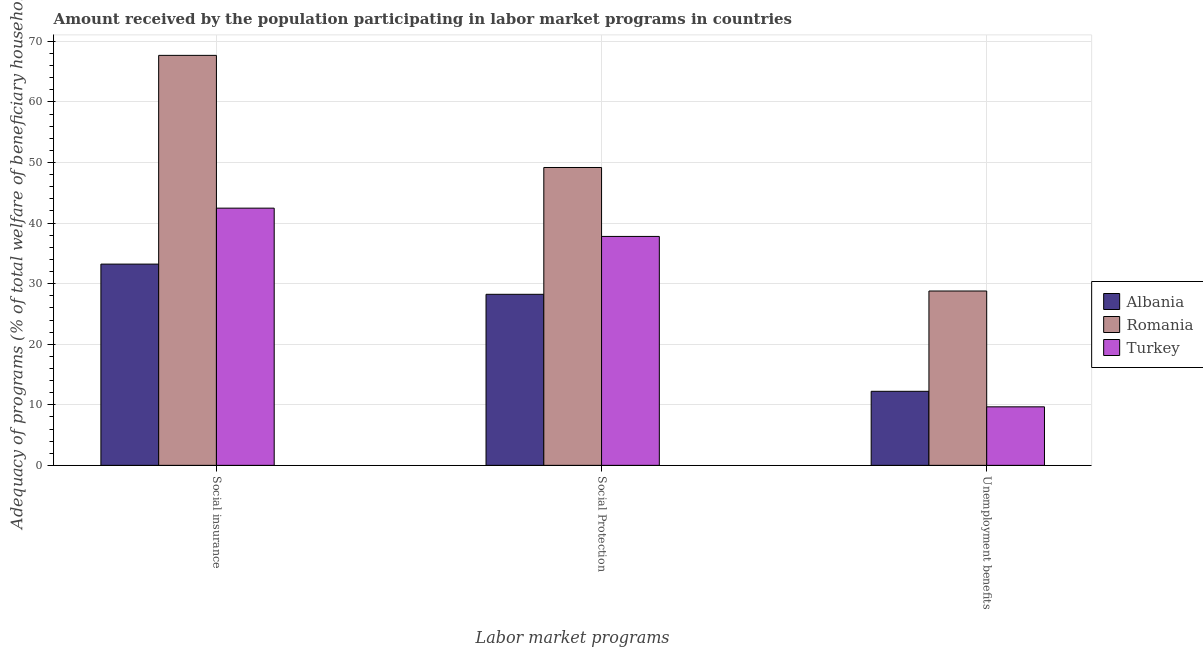How many groups of bars are there?
Offer a very short reply. 3. Are the number of bars on each tick of the X-axis equal?
Keep it short and to the point. Yes. How many bars are there on the 3rd tick from the right?
Ensure brevity in your answer.  3. What is the label of the 1st group of bars from the left?
Keep it short and to the point. Social insurance. What is the amount received by the population participating in social protection programs in Albania?
Provide a short and direct response. 28.24. Across all countries, what is the maximum amount received by the population participating in social protection programs?
Offer a very short reply. 49.18. Across all countries, what is the minimum amount received by the population participating in unemployment benefits programs?
Make the answer very short. 9.66. In which country was the amount received by the population participating in unemployment benefits programs maximum?
Ensure brevity in your answer.  Romania. In which country was the amount received by the population participating in unemployment benefits programs minimum?
Give a very brief answer. Turkey. What is the total amount received by the population participating in social insurance programs in the graph?
Keep it short and to the point. 143.4. What is the difference between the amount received by the population participating in unemployment benefits programs in Turkey and that in Romania?
Your response must be concise. -19.12. What is the difference between the amount received by the population participating in social protection programs in Turkey and the amount received by the population participating in unemployment benefits programs in Romania?
Offer a very short reply. 9.01. What is the average amount received by the population participating in unemployment benefits programs per country?
Keep it short and to the point. 16.89. What is the difference between the amount received by the population participating in unemployment benefits programs and amount received by the population participating in social protection programs in Romania?
Offer a very short reply. -20.4. In how many countries, is the amount received by the population participating in social insurance programs greater than 30 %?
Offer a very short reply. 3. What is the ratio of the amount received by the population participating in social protection programs in Romania to that in Turkey?
Provide a succinct answer. 1.3. Is the amount received by the population participating in social insurance programs in Romania less than that in Turkey?
Your answer should be compact. No. Is the difference between the amount received by the population participating in social protection programs in Romania and Turkey greater than the difference between the amount received by the population participating in unemployment benefits programs in Romania and Turkey?
Your response must be concise. No. What is the difference between the highest and the second highest amount received by the population participating in unemployment benefits programs?
Your answer should be very brief. 16.56. What is the difference between the highest and the lowest amount received by the population participating in unemployment benefits programs?
Your answer should be compact. 19.12. In how many countries, is the amount received by the population participating in unemployment benefits programs greater than the average amount received by the population participating in unemployment benefits programs taken over all countries?
Provide a short and direct response. 1. Is the sum of the amount received by the population participating in unemployment benefits programs in Turkey and Albania greater than the maximum amount received by the population participating in social insurance programs across all countries?
Ensure brevity in your answer.  No. What does the 2nd bar from the left in Social Protection represents?
Provide a short and direct response. Romania. What does the 3rd bar from the right in Social insurance represents?
Offer a very short reply. Albania. Are all the bars in the graph horizontal?
Provide a short and direct response. No. How many countries are there in the graph?
Your answer should be very brief. 3. What is the difference between two consecutive major ticks on the Y-axis?
Offer a terse response. 10. Does the graph contain any zero values?
Provide a short and direct response. No. What is the title of the graph?
Your response must be concise. Amount received by the population participating in labor market programs in countries. Does "Andorra" appear as one of the legend labels in the graph?
Make the answer very short. No. What is the label or title of the X-axis?
Ensure brevity in your answer.  Labor market programs. What is the label or title of the Y-axis?
Provide a succinct answer. Adequacy of programs (% of total welfare of beneficiary households). What is the Adequacy of programs (% of total welfare of beneficiary households) in Albania in Social insurance?
Provide a succinct answer. 33.23. What is the Adequacy of programs (% of total welfare of beneficiary households) in Romania in Social insurance?
Provide a short and direct response. 67.7. What is the Adequacy of programs (% of total welfare of beneficiary households) in Turkey in Social insurance?
Give a very brief answer. 42.47. What is the Adequacy of programs (% of total welfare of beneficiary households) in Albania in Social Protection?
Your answer should be very brief. 28.24. What is the Adequacy of programs (% of total welfare of beneficiary households) of Romania in Social Protection?
Your answer should be very brief. 49.18. What is the Adequacy of programs (% of total welfare of beneficiary households) in Turkey in Social Protection?
Keep it short and to the point. 37.8. What is the Adequacy of programs (% of total welfare of beneficiary households) in Albania in Unemployment benefits?
Offer a terse response. 12.23. What is the Adequacy of programs (% of total welfare of beneficiary households) in Romania in Unemployment benefits?
Your answer should be compact. 28.79. What is the Adequacy of programs (% of total welfare of beneficiary households) in Turkey in Unemployment benefits?
Provide a succinct answer. 9.66. Across all Labor market programs, what is the maximum Adequacy of programs (% of total welfare of beneficiary households) of Albania?
Provide a short and direct response. 33.23. Across all Labor market programs, what is the maximum Adequacy of programs (% of total welfare of beneficiary households) in Romania?
Your answer should be compact. 67.7. Across all Labor market programs, what is the maximum Adequacy of programs (% of total welfare of beneficiary households) of Turkey?
Provide a succinct answer. 42.47. Across all Labor market programs, what is the minimum Adequacy of programs (% of total welfare of beneficiary households) in Albania?
Your answer should be very brief. 12.23. Across all Labor market programs, what is the minimum Adequacy of programs (% of total welfare of beneficiary households) in Romania?
Provide a succinct answer. 28.79. Across all Labor market programs, what is the minimum Adequacy of programs (% of total welfare of beneficiary households) in Turkey?
Ensure brevity in your answer.  9.66. What is the total Adequacy of programs (% of total welfare of beneficiary households) of Albania in the graph?
Offer a very short reply. 73.7. What is the total Adequacy of programs (% of total welfare of beneficiary households) in Romania in the graph?
Give a very brief answer. 145.67. What is the total Adequacy of programs (% of total welfare of beneficiary households) of Turkey in the graph?
Provide a short and direct response. 89.93. What is the difference between the Adequacy of programs (% of total welfare of beneficiary households) in Albania in Social insurance and that in Social Protection?
Make the answer very short. 4.99. What is the difference between the Adequacy of programs (% of total welfare of beneficiary households) in Romania in Social insurance and that in Social Protection?
Provide a short and direct response. 18.51. What is the difference between the Adequacy of programs (% of total welfare of beneficiary households) of Turkey in Social insurance and that in Social Protection?
Provide a succinct answer. 4.67. What is the difference between the Adequacy of programs (% of total welfare of beneficiary households) of Albania in Social insurance and that in Unemployment benefits?
Your answer should be compact. 21.01. What is the difference between the Adequacy of programs (% of total welfare of beneficiary households) in Romania in Social insurance and that in Unemployment benefits?
Ensure brevity in your answer.  38.91. What is the difference between the Adequacy of programs (% of total welfare of beneficiary households) in Turkey in Social insurance and that in Unemployment benefits?
Give a very brief answer. 32.81. What is the difference between the Adequacy of programs (% of total welfare of beneficiary households) in Albania in Social Protection and that in Unemployment benefits?
Ensure brevity in your answer.  16.02. What is the difference between the Adequacy of programs (% of total welfare of beneficiary households) in Romania in Social Protection and that in Unemployment benefits?
Give a very brief answer. 20.4. What is the difference between the Adequacy of programs (% of total welfare of beneficiary households) of Turkey in Social Protection and that in Unemployment benefits?
Your answer should be very brief. 28.14. What is the difference between the Adequacy of programs (% of total welfare of beneficiary households) of Albania in Social insurance and the Adequacy of programs (% of total welfare of beneficiary households) of Romania in Social Protection?
Provide a succinct answer. -15.95. What is the difference between the Adequacy of programs (% of total welfare of beneficiary households) in Albania in Social insurance and the Adequacy of programs (% of total welfare of beneficiary households) in Turkey in Social Protection?
Offer a terse response. -4.57. What is the difference between the Adequacy of programs (% of total welfare of beneficiary households) in Romania in Social insurance and the Adequacy of programs (% of total welfare of beneficiary households) in Turkey in Social Protection?
Offer a terse response. 29.9. What is the difference between the Adequacy of programs (% of total welfare of beneficiary households) in Albania in Social insurance and the Adequacy of programs (% of total welfare of beneficiary households) in Romania in Unemployment benefits?
Give a very brief answer. 4.44. What is the difference between the Adequacy of programs (% of total welfare of beneficiary households) of Albania in Social insurance and the Adequacy of programs (% of total welfare of beneficiary households) of Turkey in Unemployment benefits?
Offer a very short reply. 23.57. What is the difference between the Adequacy of programs (% of total welfare of beneficiary households) in Romania in Social insurance and the Adequacy of programs (% of total welfare of beneficiary households) in Turkey in Unemployment benefits?
Keep it short and to the point. 58.03. What is the difference between the Adequacy of programs (% of total welfare of beneficiary households) of Albania in Social Protection and the Adequacy of programs (% of total welfare of beneficiary households) of Romania in Unemployment benefits?
Keep it short and to the point. -0.54. What is the difference between the Adequacy of programs (% of total welfare of beneficiary households) of Albania in Social Protection and the Adequacy of programs (% of total welfare of beneficiary households) of Turkey in Unemployment benefits?
Make the answer very short. 18.58. What is the difference between the Adequacy of programs (% of total welfare of beneficiary households) in Romania in Social Protection and the Adequacy of programs (% of total welfare of beneficiary households) in Turkey in Unemployment benefits?
Provide a succinct answer. 39.52. What is the average Adequacy of programs (% of total welfare of beneficiary households) of Albania per Labor market programs?
Provide a short and direct response. 24.57. What is the average Adequacy of programs (% of total welfare of beneficiary households) of Romania per Labor market programs?
Provide a succinct answer. 48.56. What is the average Adequacy of programs (% of total welfare of beneficiary households) in Turkey per Labor market programs?
Make the answer very short. 29.98. What is the difference between the Adequacy of programs (% of total welfare of beneficiary households) of Albania and Adequacy of programs (% of total welfare of beneficiary households) of Romania in Social insurance?
Your response must be concise. -34.47. What is the difference between the Adequacy of programs (% of total welfare of beneficiary households) in Albania and Adequacy of programs (% of total welfare of beneficiary households) in Turkey in Social insurance?
Give a very brief answer. -9.24. What is the difference between the Adequacy of programs (% of total welfare of beneficiary households) of Romania and Adequacy of programs (% of total welfare of beneficiary households) of Turkey in Social insurance?
Your response must be concise. 25.23. What is the difference between the Adequacy of programs (% of total welfare of beneficiary households) in Albania and Adequacy of programs (% of total welfare of beneficiary households) in Romania in Social Protection?
Your answer should be very brief. -20.94. What is the difference between the Adequacy of programs (% of total welfare of beneficiary households) of Albania and Adequacy of programs (% of total welfare of beneficiary households) of Turkey in Social Protection?
Provide a short and direct response. -9.56. What is the difference between the Adequacy of programs (% of total welfare of beneficiary households) in Romania and Adequacy of programs (% of total welfare of beneficiary households) in Turkey in Social Protection?
Keep it short and to the point. 11.38. What is the difference between the Adequacy of programs (% of total welfare of beneficiary households) of Albania and Adequacy of programs (% of total welfare of beneficiary households) of Romania in Unemployment benefits?
Ensure brevity in your answer.  -16.56. What is the difference between the Adequacy of programs (% of total welfare of beneficiary households) of Albania and Adequacy of programs (% of total welfare of beneficiary households) of Turkey in Unemployment benefits?
Give a very brief answer. 2.56. What is the difference between the Adequacy of programs (% of total welfare of beneficiary households) in Romania and Adequacy of programs (% of total welfare of beneficiary households) in Turkey in Unemployment benefits?
Ensure brevity in your answer.  19.12. What is the ratio of the Adequacy of programs (% of total welfare of beneficiary households) in Albania in Social insurance to that in Social Protection?
Ensure brevity in your answer.  1.18. What is the ratio of the Adequacy of programs (% of total welfare of beneficiary households) in Romania in Social insurance to that in Social Protection?
Your answer should be compact. 1.38. What is the ratio of the Adequacy of programs (% of total welfare of beneficiary households) in Turkey in Social insurance to that in Social Protection?
Your response must be concise. 1.12. What is the ratio of the Adequacy of programs (% of total welfare of beneficiary households) of Albania in Social insurance to that in Unemployment benefits?
Your answer should be compact. 2.72. What is the ratio of the Adequacy of programs (% of total welfare of beneficiary households) in Romania in Social insurance to that in Unemployment benefits?
Your response must be concise. 2.35. What is the ratio of the Adequacy of programs (% of total welfare of beneficiary households) in Turkey in Social insurance to that in Unemployment benefits?
Provide a succinct answer. 4.39. What is the ratio of the Adequacy of programs (% of total welfare of beneficiary households) of Albania in Social Protection to that in Unemployment benefits?
Your answer should be very brief. 2.31. What is the ratio of the Adequacy of programs (% of total welfare of beneficiary households) in Romania in Social Protection to that in Unemployment benefits?
Make the answer very short. 1.71. What is the ratio of the Adequacy of programs (% of total welfare of beneficiary households) in Turkey in Social Protection to that in Unemployment benefits?
Keep it short and to the point. 3.91. What is the difference between the highest and the second highest Adequacy of programs (% of total welfare of beneficiary households) of Albania?
Keep it short and to the point. 4.99. What is the difference between the highest and the second highest Adequacy of programs (% of total welfare of beneficiary households) of Romania?
Your answer should be very brief. 18.51. What is the difference between the highest and the second highest Adequacy of programs (% of total welfare of beneficiary households) in Turkey?
Your answer should be very brief. 4.67. What is the difference between the highest and the lowest Adequacy of programs (% of total welfare of beneficiary households) of Albania?
Your answer should be very brief. 21.01. What is the difference between the highest and the lowest Adequacy of programs (% of total welfare of beneficiary households) of Romania?
Offer a very short reply. 38.91. What is the difference between the highest and the lowest Adequacy of programs (% of total welfare of beneficiary households) of Turkey?
Make the answer very short. 32.81. 